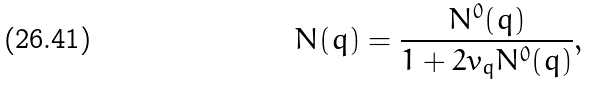<formula> <loc_0><loc_0><loc_500><loc_500>N ( q ) = \frac { N ^ { 0 } ( q ) } { 1 + 2 v _ { q } N ^ { 0 } ( q ) } ,</formula> 